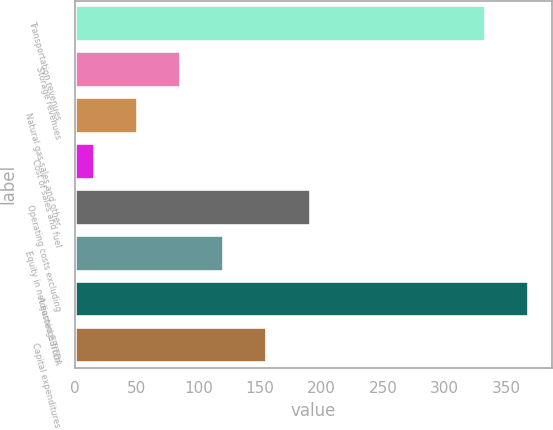Convert chart to OTSL. <chart><loc_0><loc_0><loc_500><loc_500><bar_chart><fcel>Transportation revenues<fcel>Storage revenues<fcel>Natural gas sales and other<fcel>Cost of sales and fuel<fcel>Operating costs excluding<fcel>Equity in net earnings from<fcel>Adjusted EBITDA<fcel>Capital expenditures<nl><fcel>333.7<fcel>86.06<fcel>51.03<fcel>16<fcel>191.15<fcel>121.09<fcel>368.73<fcel>156.12<nl></chart> 